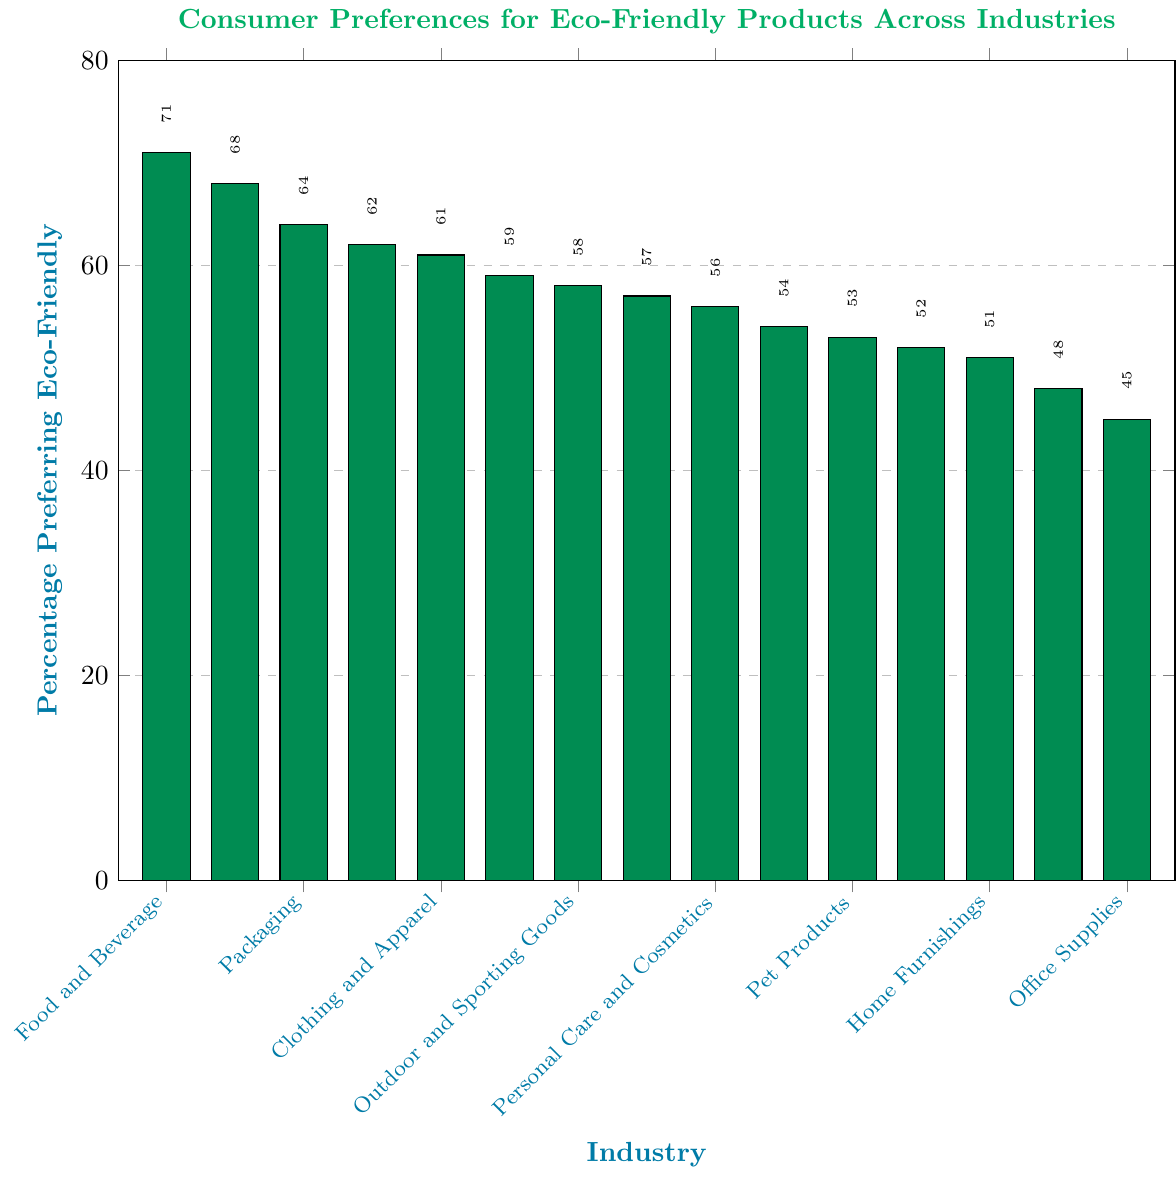Which industry has the highest percentage of consumers preferring eco-friendly products? The industry with the tallest bar represents the highest percentage of consumers preferring eco-friendly products. The tallest bar belongs to Cleaning Products.
Answer: Cleaning Products What is the difference in percentages of consumers preferring eco-friendly products between the Food and Beverage and Automobiles industries? The percentage of consumers preferring eco-friendly products in the Food and Beverage industry is 68%, and in the Automobiles industry is 45%. The difference is 68% - 45% = 23%.
Answer: 23% Which industry has the lowest percentage of consumers preferring eco-friendly products? The industry with the shortest bar represents the lowest percentage of consumers preferring eco-friendly products. The shortest bar belongs to Automobiles.
Answer: Automobiles What is the average percentage of consumers preferring eco-friendly products among the top three industries? The top three industries are Cleaning Products (71%), Food and Beverage (68%), and Packaging (64%). Summing these values gives 71 + 68 + 64 = 203. The average is 203 / 3 ≈ 67.67%.
Answer: 67.67% Compare the percentage of consumers preferring eco-friendly products between Outdoor and Sporting Goods and Office Supplies. Which one has the higher percentage and by how much? Outdoor and Sporting Goods has 61%, while Office Supplies has 56%. Outdoor and Sporting Goods has a higher percentage by 61% - 56% = 5%.
Answer: Outdoor and Sporting Goods, 5% Which industries have a percentage of consumers preferring eco-friendly products greater than 60%? The industries with a percentage greater than 60% are Cleaning Products, Food and Beverage, Packaging, Clothing and Apparel, and Outdoor and Sporting Goods.
Answer: Cleaning Products, Food and Beverage, Packaging, Clothing and Apparel, Outdoor and Sporting Goods How many industries have a percentage of consumers preferring eco-friendly products below 50%? The industries below 50% are Construction Materials and Automobiles, giving us 2 industries.
Answer: 2 What's the median percentage of consumers preferring eco-friendly products across all industries? Arrange the percentages in ascending order: [45, 48, 51, 52, 53, 54, 56, 57, 58, 59, 61, 62, 64, 68, 71]. The median is the middle value, which is the 8th value in this ordered list: 57%.
Answer: 57% How does the percentage of consumers preferring eco-friendly products in the Electronics industry compare to the overall average across all industries? First, calculate the total sum of percentages: 68 + 62 + 59 + 51 + 57 + 45 + 71 + 64 + 48 + 53 + 56 + 61 + 54 + 58 + 52 = 809. The overall average is 809 / 15 ≈ 53.93%. Electronics has 51%, which is below the overall average of 53.93%.
Answer: Below average What percentage of consumers prefer eco-friendly products in the industry with the third lowest percentage? Arranging the percentages in ascending order: [45, 48, 51, 52, 53, 54, 56, 57, 58, 59, 61, 62, 64, 68, 71], the third lowest is Electronics with 51%.
Answer: 51% 